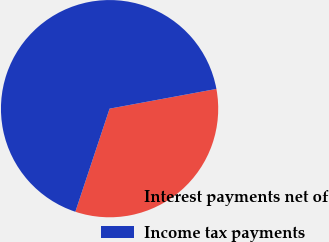Convert chart to OTSL. <chart><loc_0><loc_0><loc_500><loc_500><pie_chart><fcel>Interest payments net of<fcel>Income tax payments<nl><fcel>33.01%<fcel>66.99%<nl></chart> 